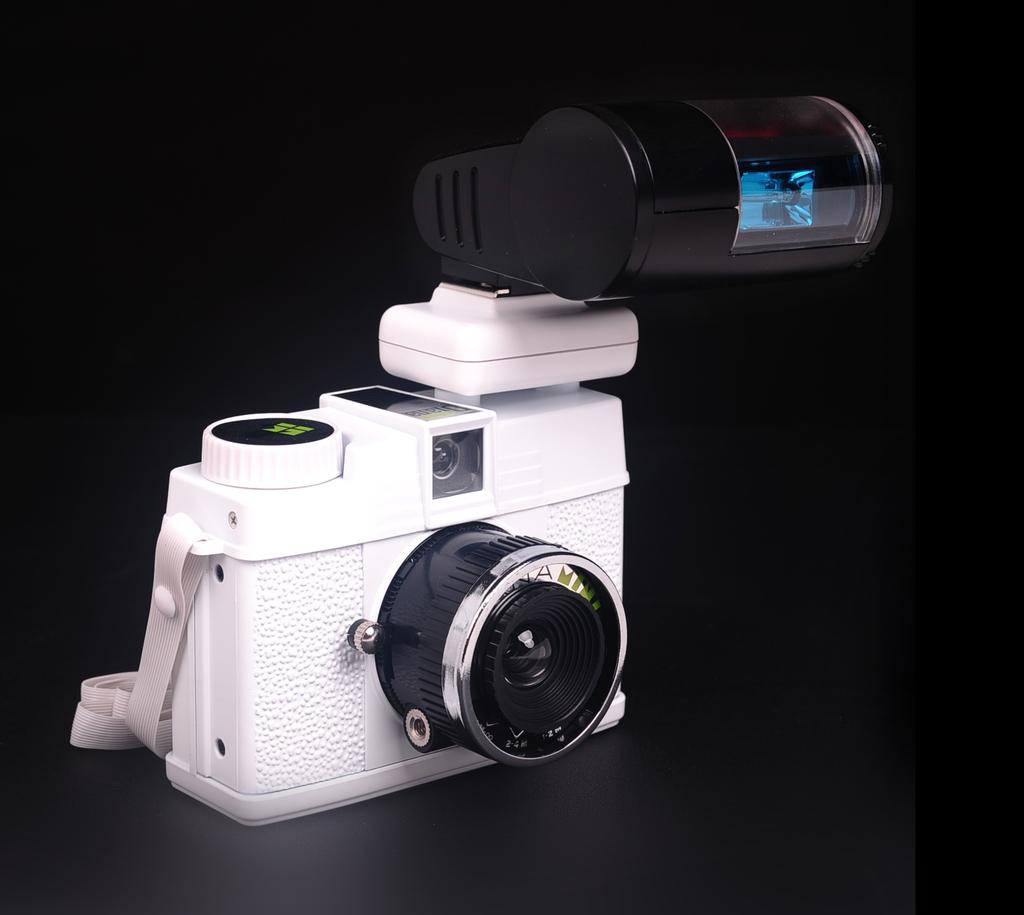What object is the main focus of the image? There is a camera in the image. Can you describe the background of the image? The background of the image is dark. What type of guitar is visible in the image? There is no guitar present in the image; it only features a camera. 